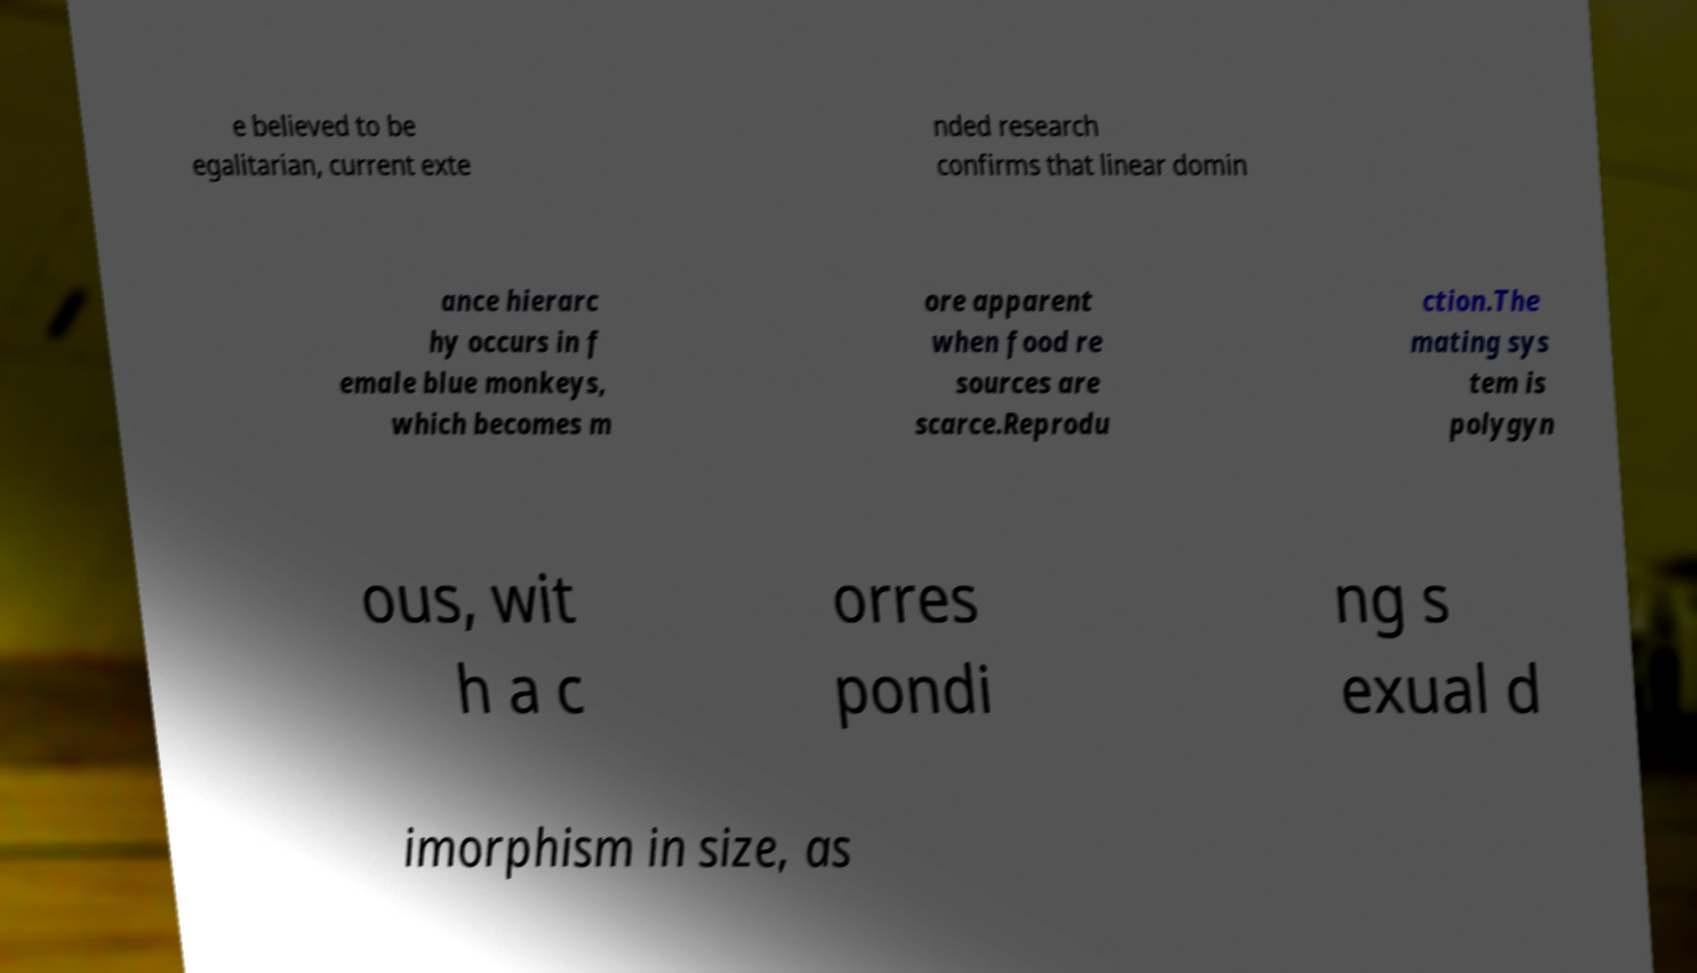Please identify and transcribe the text found in this image. e believed to be egalitarian, current exte nded research confirms that linear domin ance hierarc hy occurs in f emale blue monkeys, which becomes m ore apparent when food re sources are scarce.Reprodu ction.The mating sys tem is polygyn ous, wit h a c orres pondi ng s exual d imorphism in size, as 